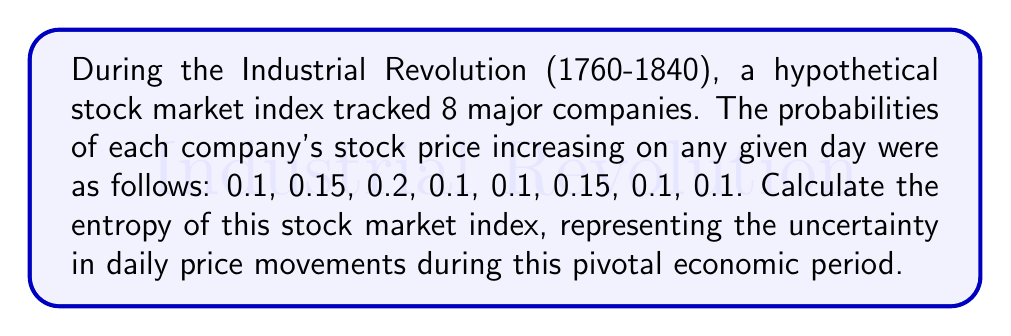Could you help me with this problem? To calculate the entropy of the stock market index, we'll use Shannon's entropy formula:

$$H = -\sum_{i=1}^{n} p_i \log_2(p_i)$$

Where $H$ is the entropy, $p_i$ is the probability of each outcome, and $n$ is the number of possible outcomes.

Let's calculate each term:

1. $-0.1 \log_2(0.1) \approx 0.3322$
2. $-0.15 \log_2(0.15) \approx 0.4101$
3. $-0.2 \log_2(0.2) \approx 0.4644$
4. $-0.1 \log_2(0.1) \approx 0.3322$
5. $-0.1 \log_2(0.1) \approx 0.3322$
6. $-0.15 \log_2(0.15) \approx 0.4101$
7. $-0.1 \log_2(0.1) \approx 0.3322$
8. $-0.1 \log_2(0.1) \approx 0.3322$

Now, we sum all these terms:

$$H = 0.3322 + 0.4101 + 0.4644 + 0.3322 + 0.3322 + 0.4101 + 0.3322 + 0.3322$$

$$H \approx 2.9456 \text{ bits}$$

This value represents the average amount of information or uncertainty in the daily price movements of the stock market index during the Industrial Revolution period.
Answer: The entropy of the stock market index is approximately 2.9456 bits. 